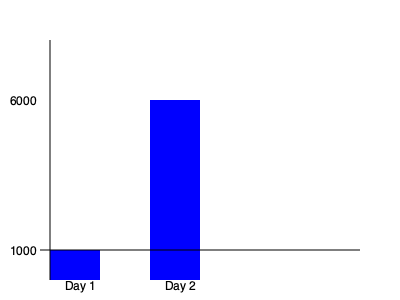A high-frequency trading algorithm executed 1000 trades on Day 1 and 6000 trades on Day 2. Calculate the percentage increase in trading volume from Day 1 to Day 2. To calculate the percentage increase in trading volume, we'll follow these steps:

1. Identify the initial and final values:
   Initial value (Day 1): 1000 trades
   Final value (Day 2): 6000 trades

2. Calculate the difference between the final and initial values:
   Difference = Final value - Initial value
   Difference = 6000 - 1000 = 5000 trades

3. Divide the difference by the initial value:
   $\frac{\text{Difference}}{\text{Initial value}} = \frac{5000}{1000} = 5$

4. Multiply the result by 100 to get the percentage:
   Percentage increase = $5 \times 100\% = 500\%$

Therefore, the percentage increase in trading volume from Day 1 to Day 2 is 500%.
Answer: 500% 